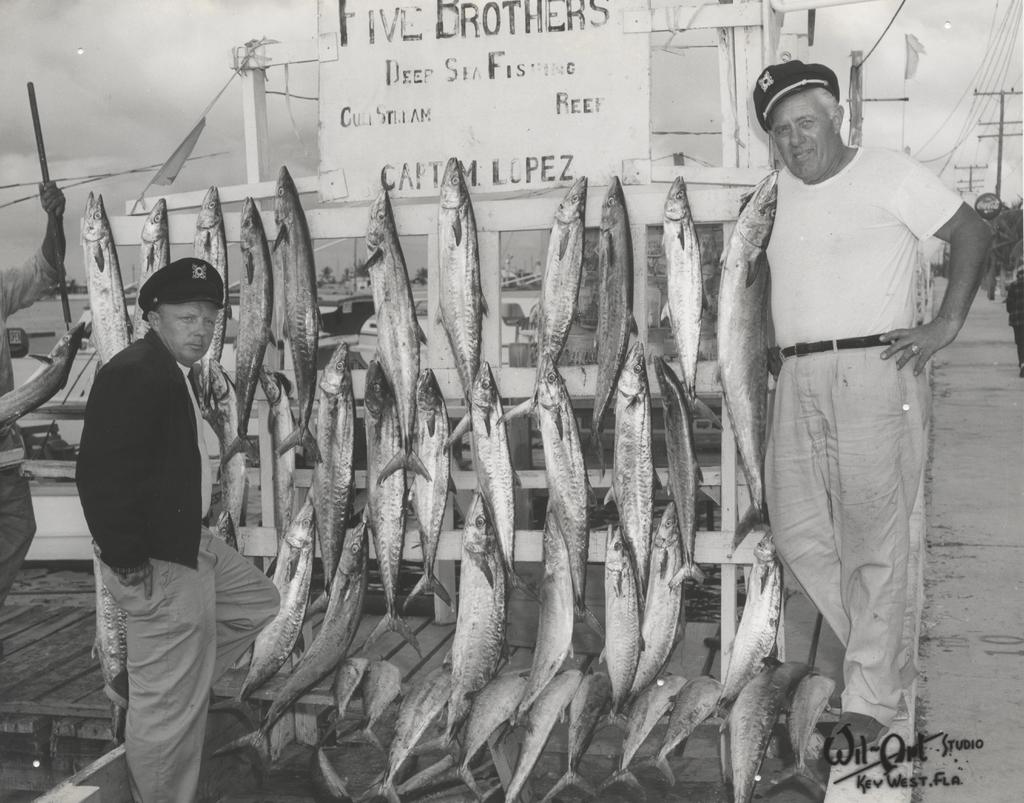What is the color scheme of the image? The image is black and white. How many people are in the image? There are two men standing in the image. What are the men doing in the image? The men are posing for a photo. What can be seen hanging in the background of the image? There are fishes hanged on a wooden background in the image. Where is the crib located in the image? There is no crib present in the image. What type of wall is visible in the image? The image is black and white, so it is not possible to determine the type of wall from the image. 